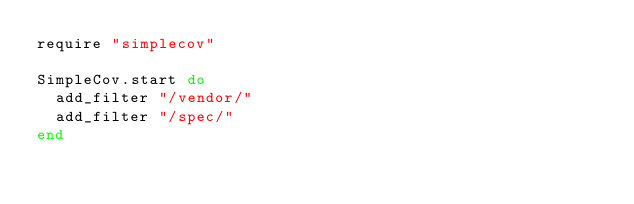<code> <loc_0><loc_0><loc_500><loc_500><_Ruby_>require "simplecov"

SimpleCov.start do
  add_filter "/vendor/"
  add_filter "/spec/"
end
</code> 